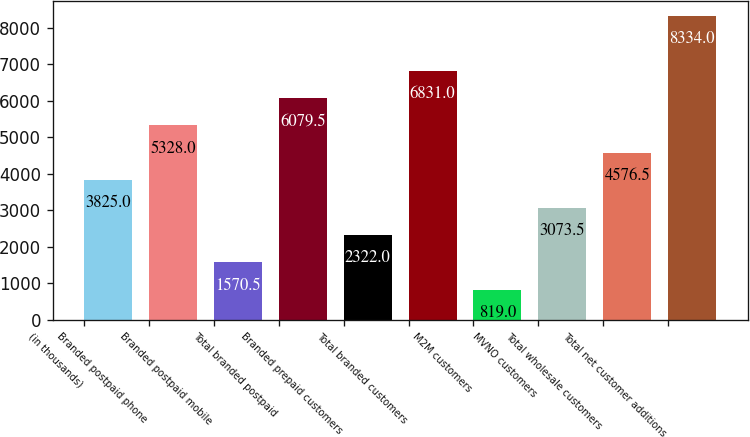Convert chart. <chart><loc_0><loc_0><loc_500><loc_500><bar_chart><fcel>(in thousands)<fcel>Branded postpaid phone<fcel>Branded postpaid mobile<fcel>Total branded postpaid<fcel>Branded prepaid customers<fcel>Total branded customers<fcel>M2M customers<fcel>MVNO customers<fcel>Total wholesale customers<fcel>Total net customer additions<nl><fcel>3825<fcel>5328<fcel>1570.5<fcel>6079.5<fcel>2322<fcel>6831<fcel>819<fcel>3073.5<fcel>4576.5<fcel>8334<nl></chart> 